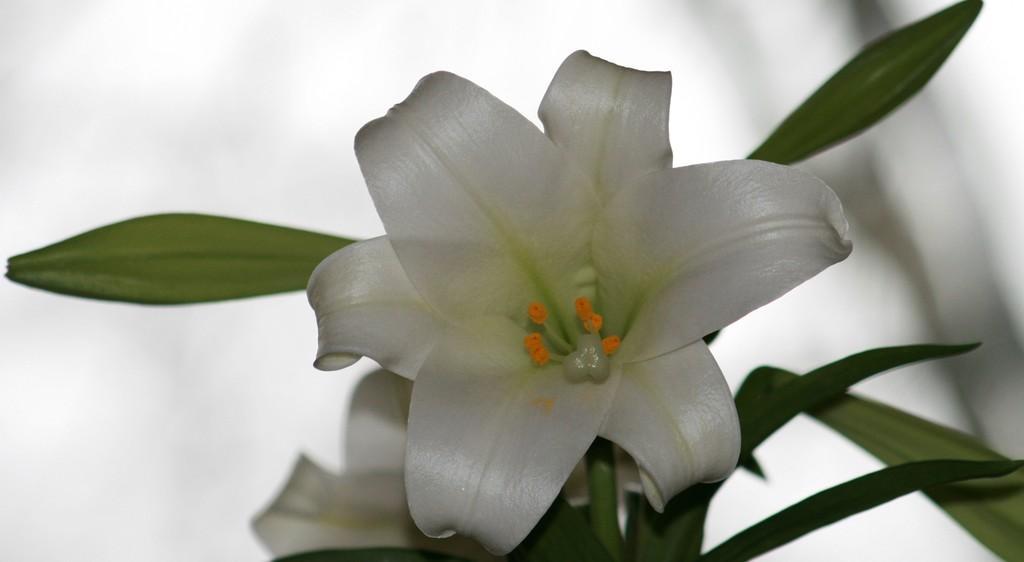Could you give a brief overview of what you see in this image? There is a white lily and leaves. The background is blurred. 